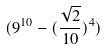<formula> <loc_0><loc_0><loc_500><loc_500>( 9 ^ { 1 0 } - ( \frac { \sqrt { 2 } } { 1 0 } ) ^ { 4 } )</formula> 